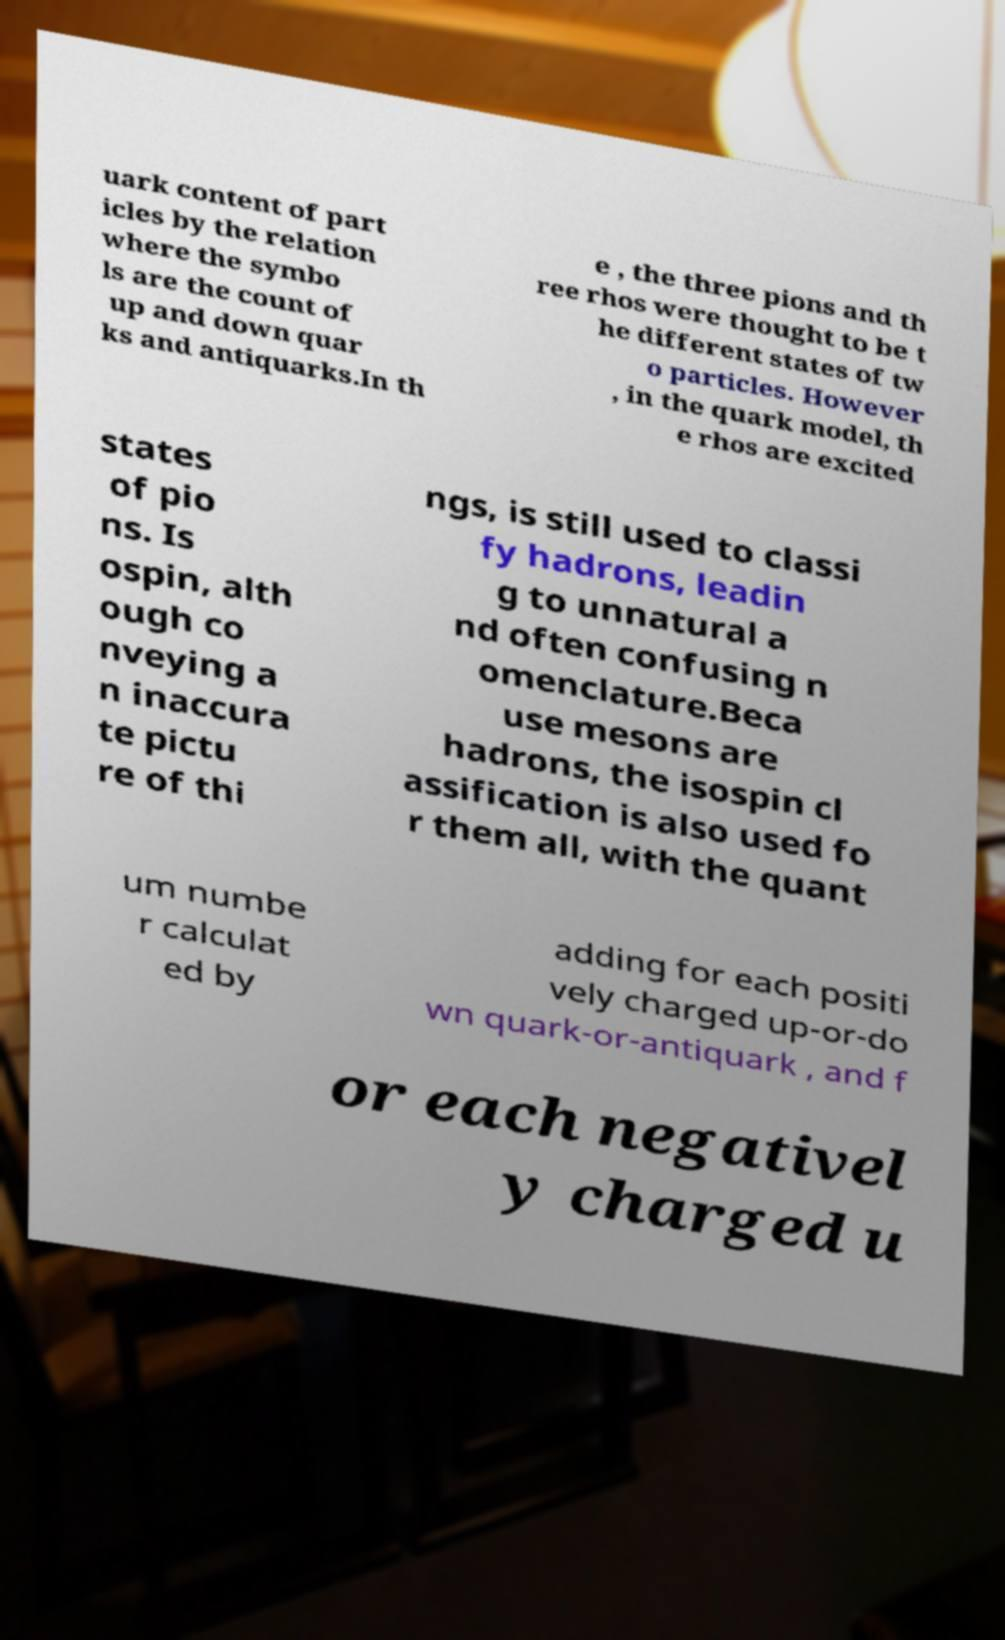For documentation purposes, I need the text within this image transcribed. Could you provide that? uark content of part icles by the relation where the symbo ls are the count of up and down quar ks and antiquarks.In th e , the three pions and th ree rhos were thought to be t he different states of tw o particles. However , in the quark model, th e rhos are excited states of pio ns. Is ospin, alth ough co nveying a n inaccura te pictu re of thi ngs, is still used to classi fy hadrons, leadin g to unnatural a nd often confusing n omenclature.Beca use mesons are hadrons, the isospin cl assification is also used fo r them all, with the quant um numbe r calculat ed by adding for each positi vely charged up-or-do wn quark-or-antiquark , and f or each negativel y charged u 